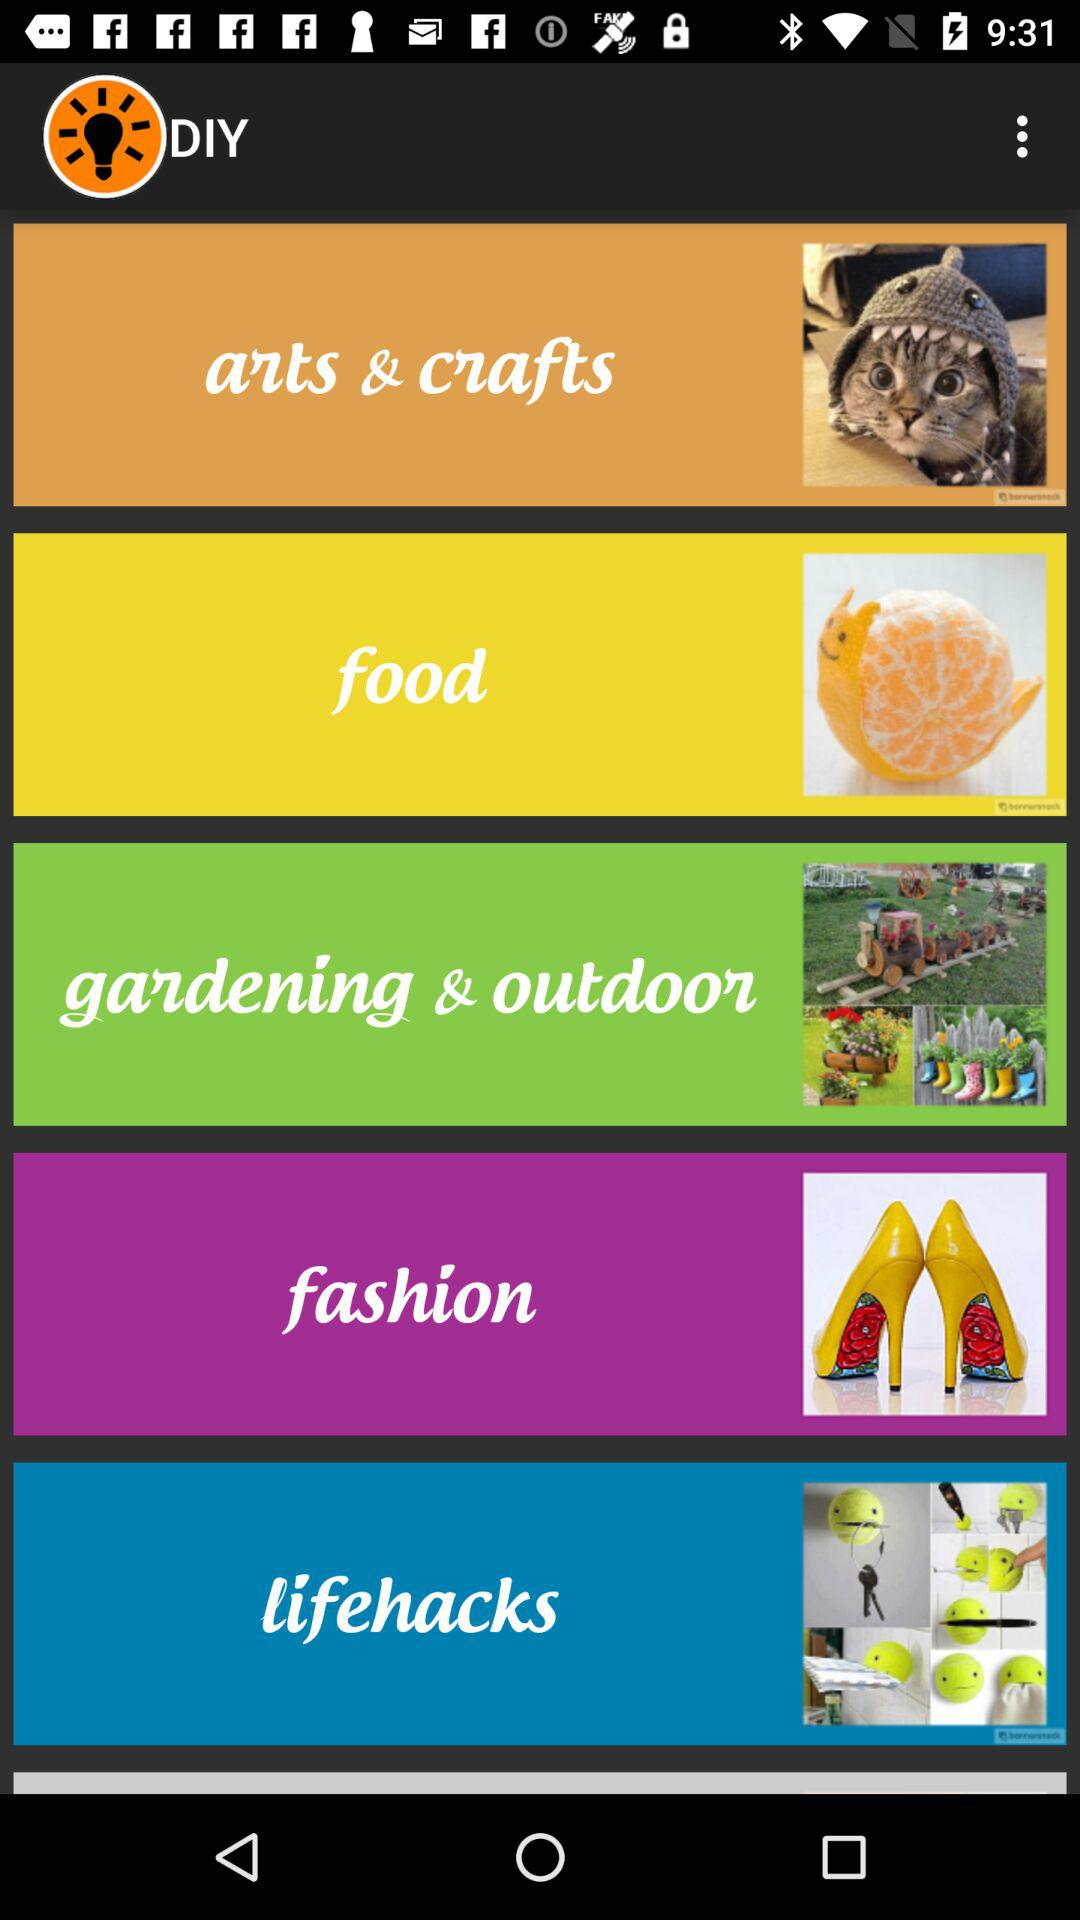What is the application name? The application name is "DIY". 